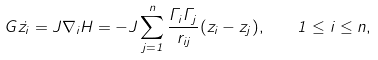Convert formula to latex. <formula><loc_0><loc_0><loc_500><loc_500>G \dot { z _ { i } } = J \nabla _ { i } H = - J \sum _ { j = 1 } ^ { n } \frac { \Gamma _ { i } \Gamma _ { j } } { r _ { i j } } ( z _ { i } - z _ { j } ) , \quad 1 \leq i \leq n ,</formula> 